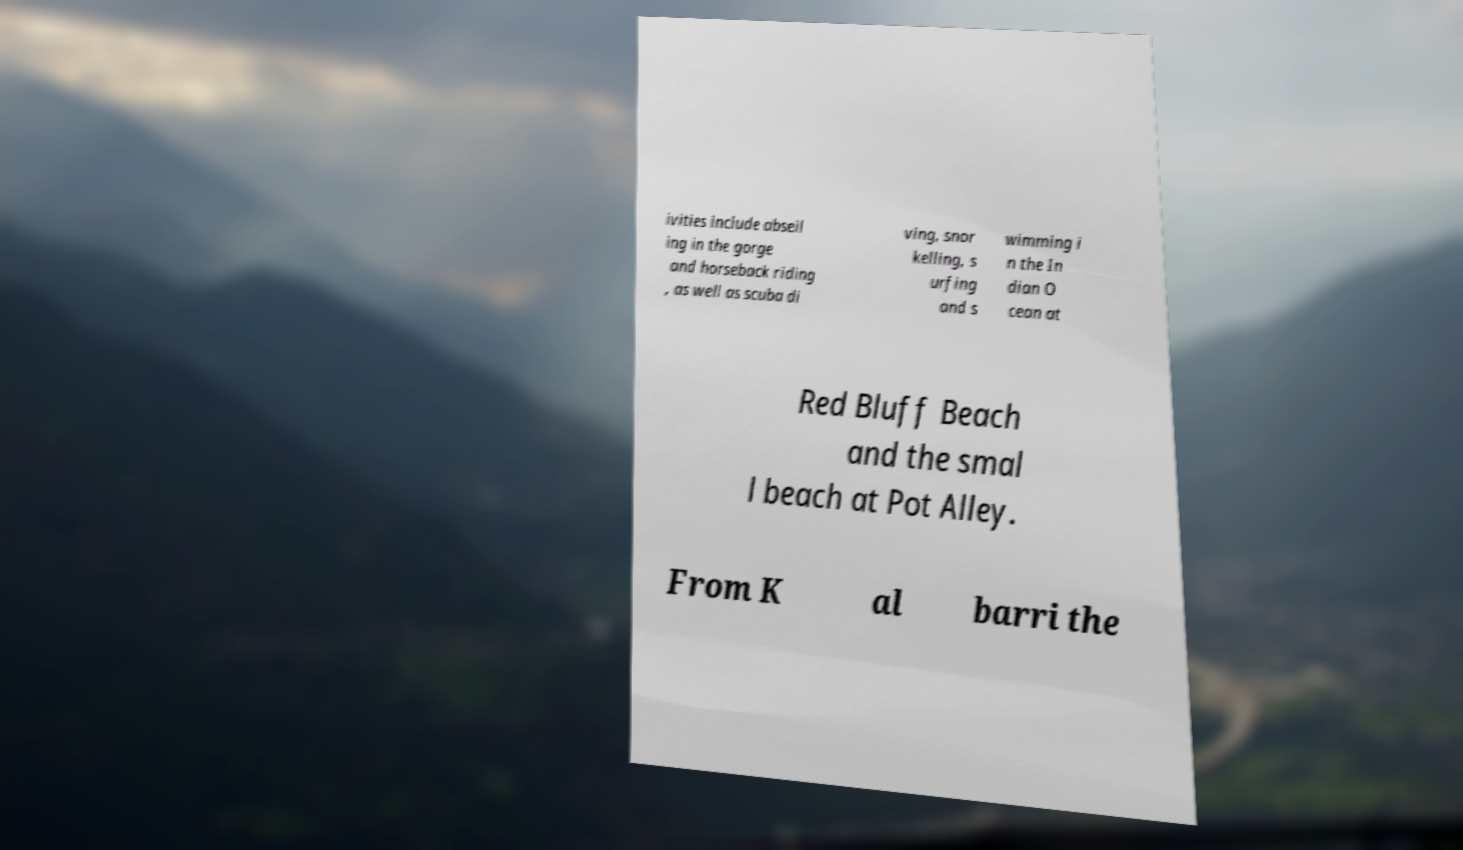Can you accurately transcribe the text from the provided image for me? ivities include abseil ing in the gorge and horseback riding , as well as scuba di ving, snor kelling, s urfing and s wimming i n the In dian O cean at Red Bluff Beach and the smal l beach at Pot Alley. From K al barri the 